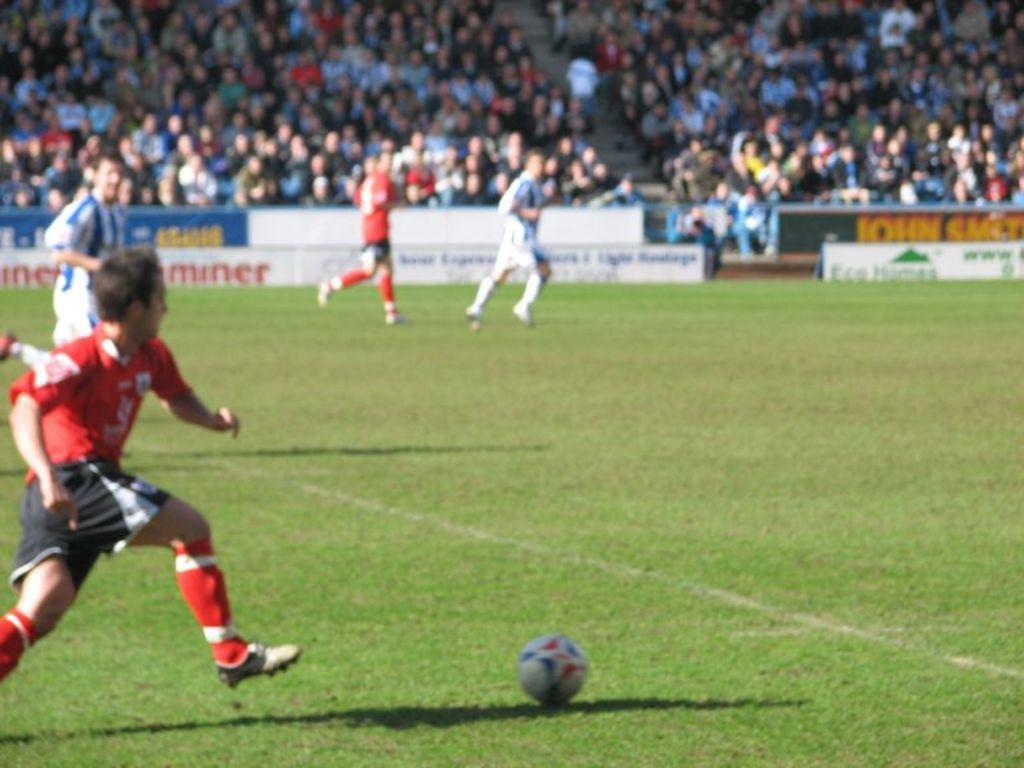Provide a one-sentence caption for the provided image. Players race down the field towards a sign that says John Smith. 